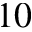<formula> <loc_0><loc_0><loc_500><loc_500>1 0</formula> 